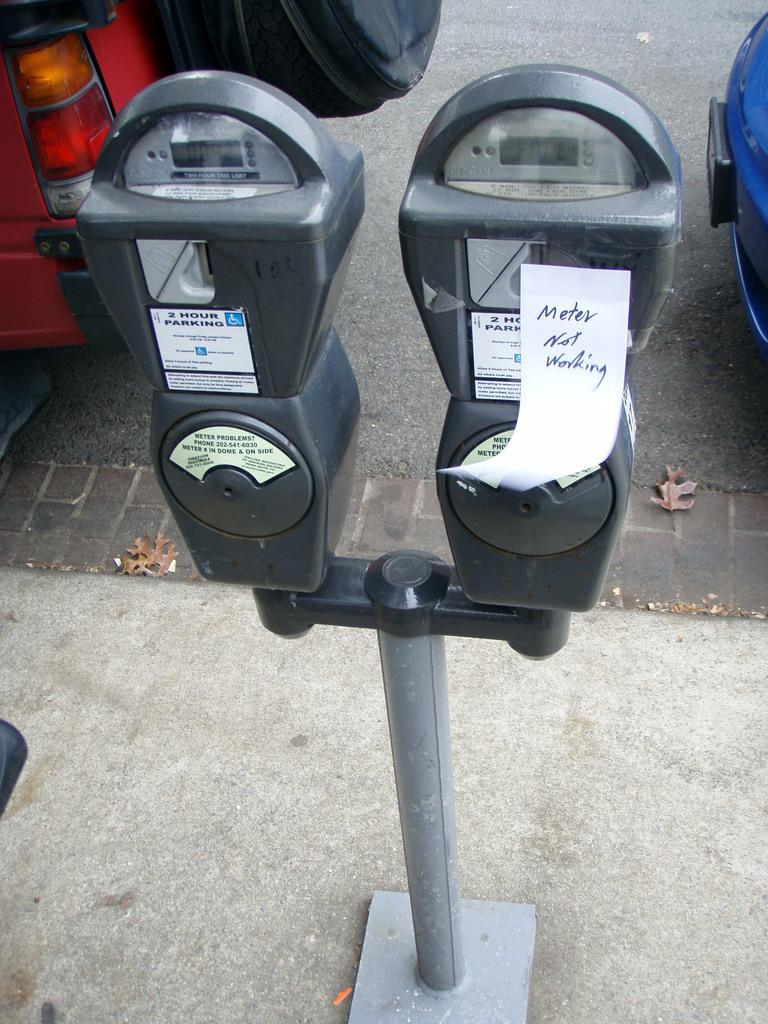What objects are present on the parking meters in the image? There is paper on the parking meters in the image. How many parking meters can be seen in the image? There are two parking meters in the image. What can be seen in the background of the image? There are two vehicles visible in the background of the image. Where are the vehicles located in relation to the parking meters? The vehicles are on the road in the background of the image. Is there a hose attached to the water source near the parking meters? There is no hose or water source present in the image. 